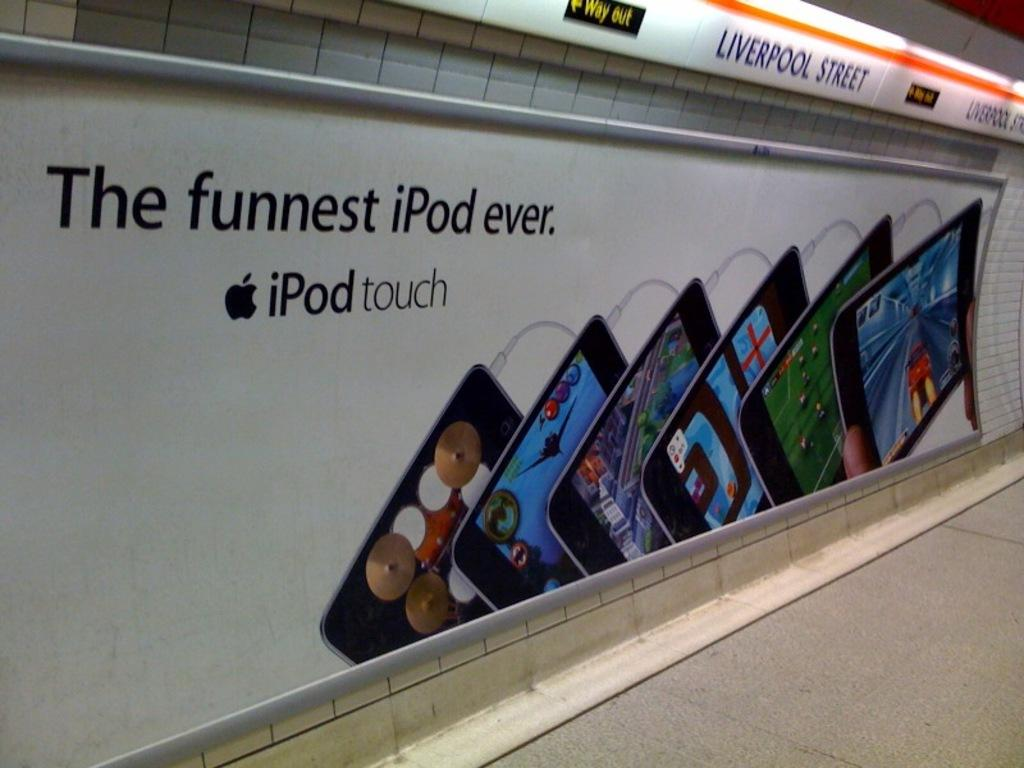<image>
Provide a brief description of the given image. An advertisement for the funnest iPod ever near Liverpool Street.. 